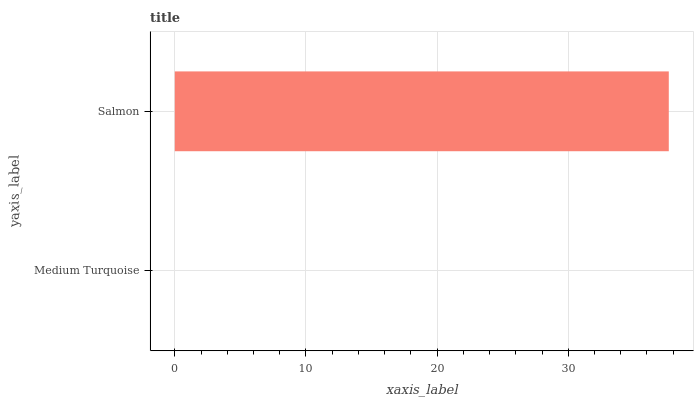Is Medium Turquoise the minimum?
Answer yes or no. Yes. Is Salmon the maximum?
Answer yes or no. Yes. Is Salmon the minimum?
Answer yes or no. No. Is Salmon greater than Medium Turquoise?
Answer yes or no. Yes. Is Medium Turquoise less than Salmon?
Answer yes or no. Yes. Is Medium Turquoise greater than Salmon?
Answer yes or no. No. Is Salmon less than Medium Turquoise?
Answer yes or no. No. Is Salmon the high median?
Answer yes or no. Yes. Is Medium Turquoise the low median?
Answer yes or no. Yes. Is Medium Turquoise the high median?
Answer yes or no. No. Is Salmon the low median?
Answer yes or no. No. 